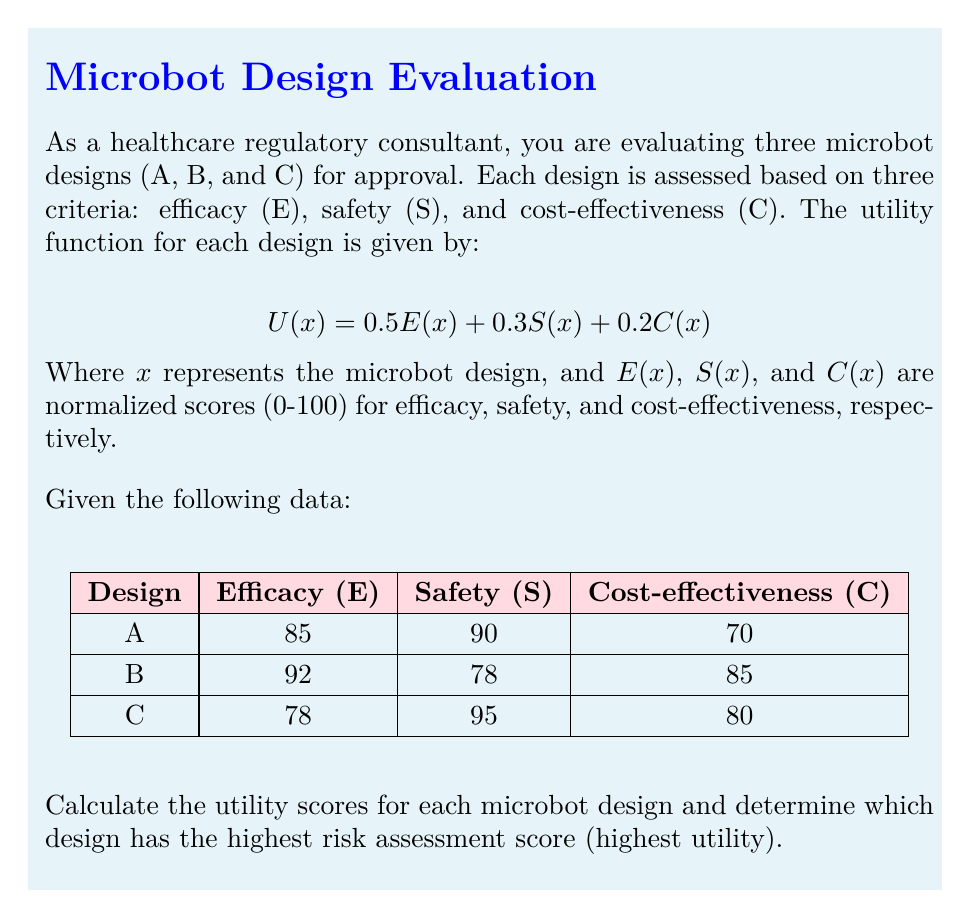Help me with this question. To solve this problem, we'll follow these steps:

1. Recall the utility function:
   $$U(x) = 0.5E(x) + 0.3S(x) + 0.2C(x)$$

2. Calculate the utility score for each design:

   For Design A:
   $$U(A) = 0.5(85) + 0.3(90) + 0.2(70)$$
   $$U(A) = 42.5 + 27 + 14 = 83.5$$

   For Design B:
   $$U(B) = 0.5(92) + 0.3(78) + 0.2(85)$$
   $$U(B) = 46 + 23.4 + 17 = 86.4$$

   For Design C:
   $$U(C) = 0.5(78) + 0.3(95) + 0.2(80)$$
   $$U(C) = 39 + 28.5 + 16 = 83.5$$

3. Compare the utility scores:
   Design A: 83.5
   Design B: 86.4
   Design C: 83.5

4. Identify the design with the highest utility score:
   Design B has the highest score of 86.4, which represents the highest risk assessment score.
Answer: Design B, with a utility score of 86.4 